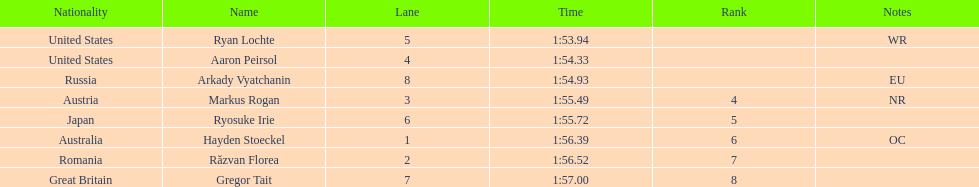Did austria or russia rank higher? Russia. 